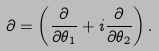<formula> <loc_0><loc_0><loc_500><loc_500>\partial = \left ( \frac { \partial } { \partial \theta _ { 1 } } + i \frac { \partial } { \partial \theta _ { 2 } } \right ) .</formula> 